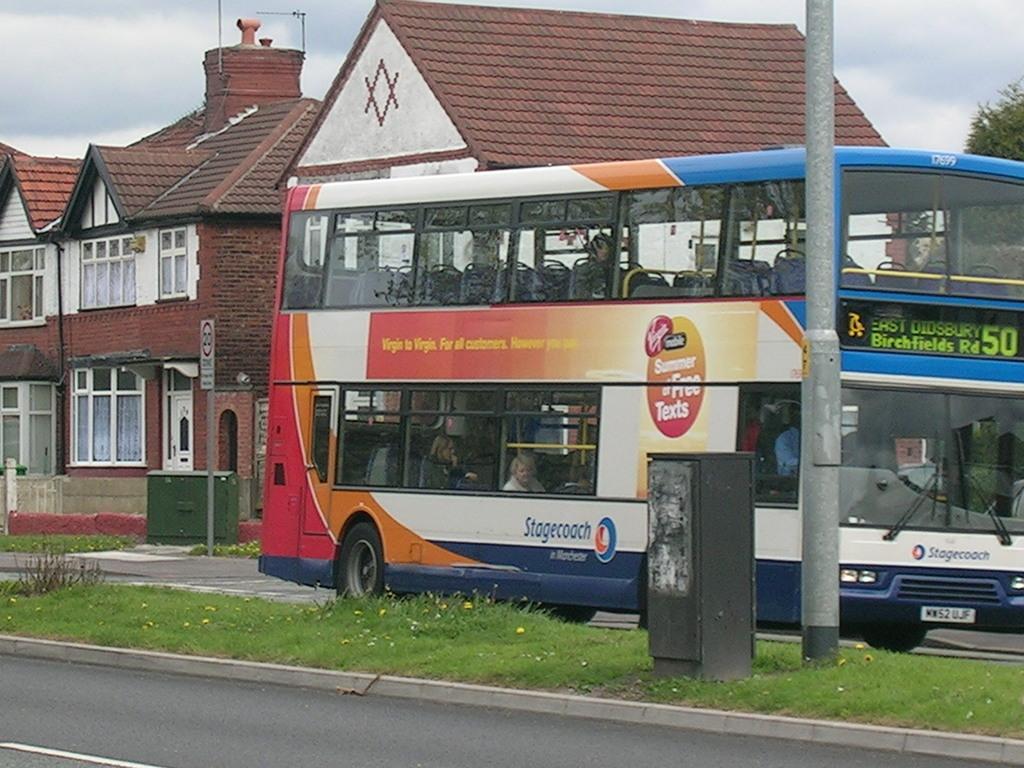What number is on the bus?
Make the answer very short. 50. From what direction is the bus going?
Ensure brevity in your answer.  East. 